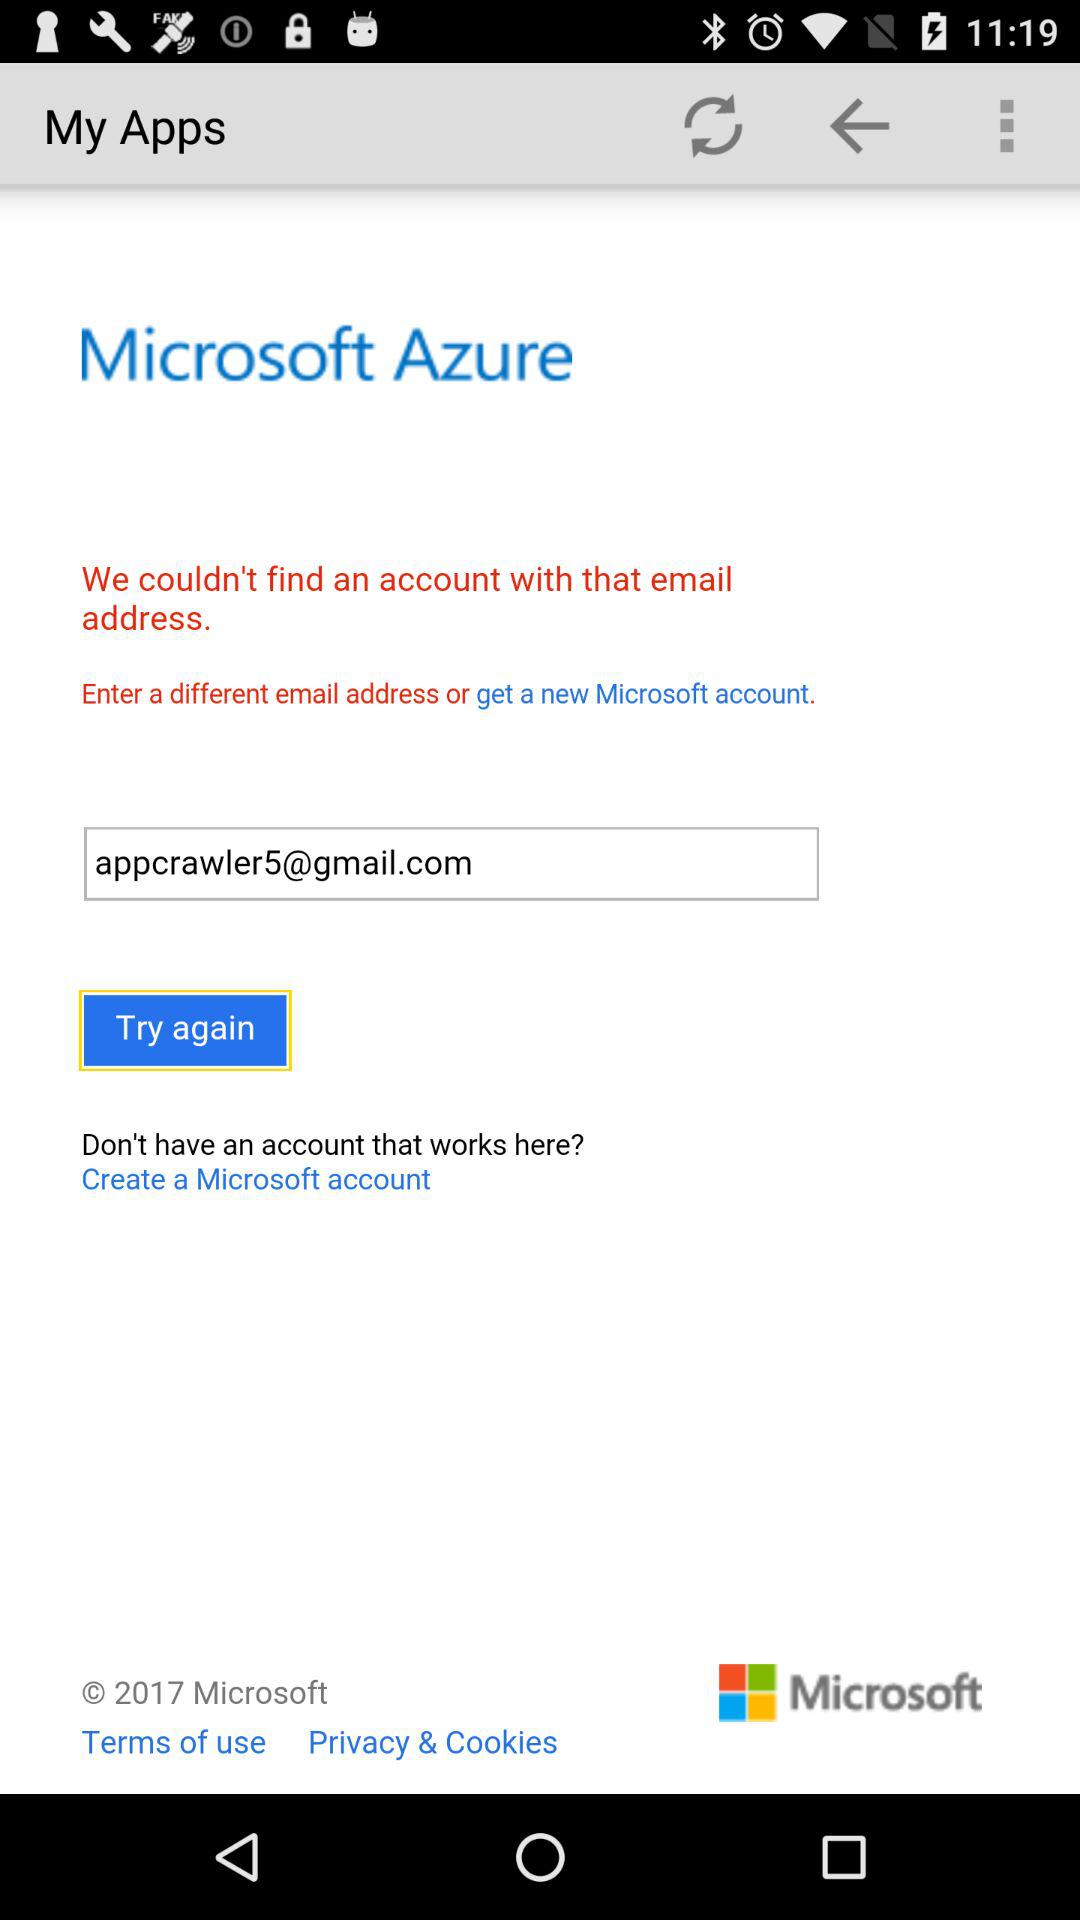What is the name of the application? The name of the application is "Microsoft Azure". 